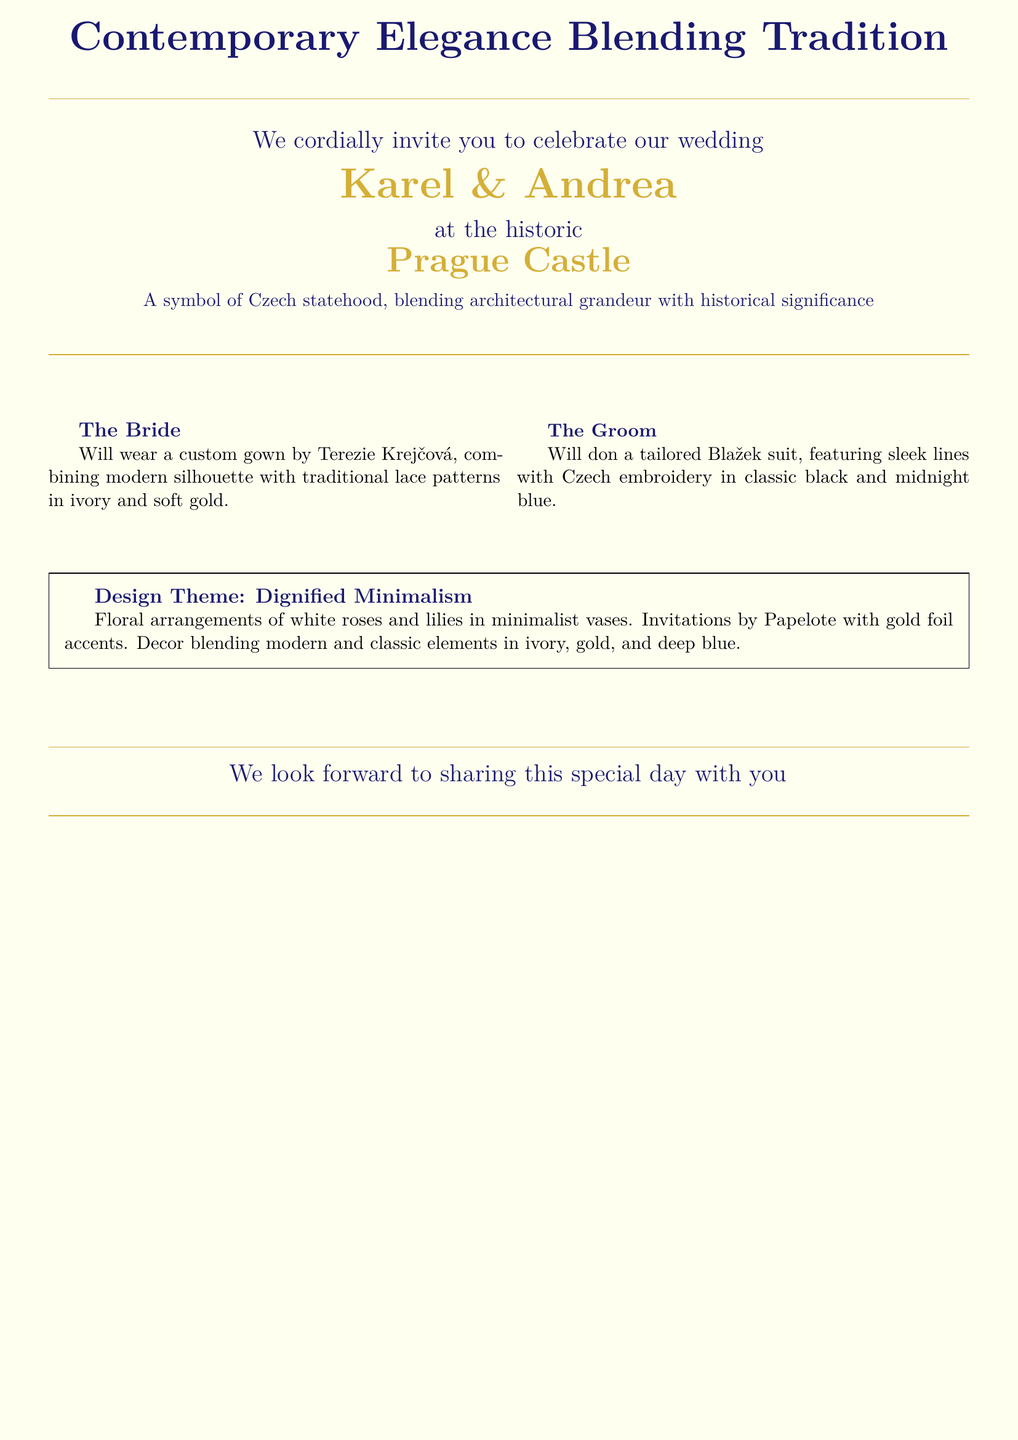What is the name of the bride? The name of the bride is explicitly mentioned in the invitation.
Answer: Andrea What is the wedding ceremony location? The location of the wedding ceremony is prominently displayed in the center of the invitation.
Answer: Prague Castle What color palette is inspired by governmental ceremonial invitations? The invitation mentions an elegant color palette that is inspired by governmental ceremonial invitations, referencing the choice of colors used.
Answer: Ivory, soft gold, midnight blue Who is making the bride's gown? The document specifies the designer responsible for the bride's gown.
Answer: Terezie Krejčová What is the design theme described in the invitation? The document contains a section that outlines the overall theme of the wedding invitation.
Answer: Dignified Minimalism What color are the floral arrangements mentioned? The invitation describes the color of the flowers used for decorations during the wedding.
Answer: White What material is used for the invitations? The type of material used for the invitations is specified in a statement about their creation.
Answer: Papelote What is the groom's suit color? The color of the groom's suit is indicated in the document.
Answer: Black and midnight blue What elements are described in the decor? The invitation details the kind of elements integrated into the wedding decor.
Answer: Modern and classic elements 